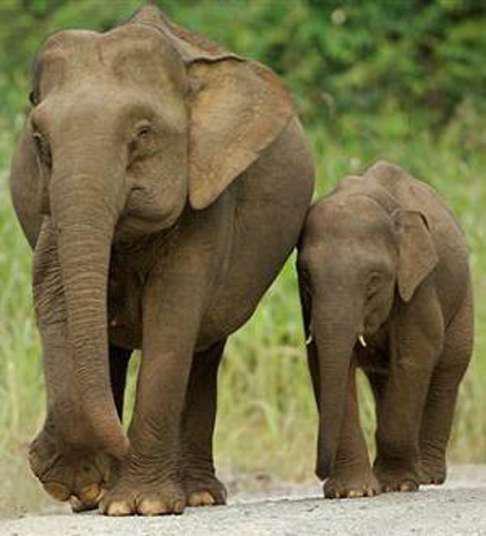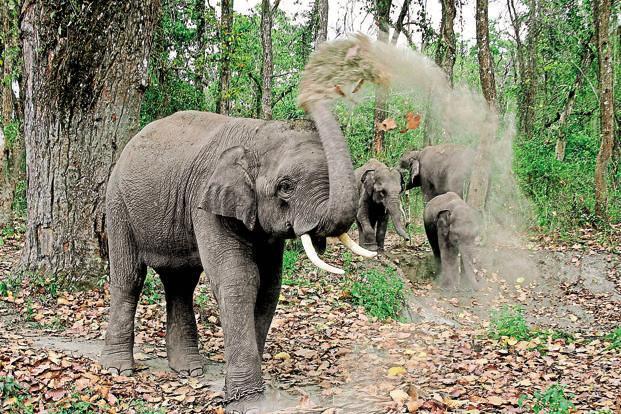The first image is the image on the left, the second image is the image on the right. Assess this claim about the two images: "Multiple pairs of elephant tusks are visible.". Correct or not? Answer yes or no. Yes. The first image is the image on the left, the second image is the image on the right. Assess this claim about the two images: "The photo on the right contains a single elephant.". Correct or not? Answer yes or no. No. 